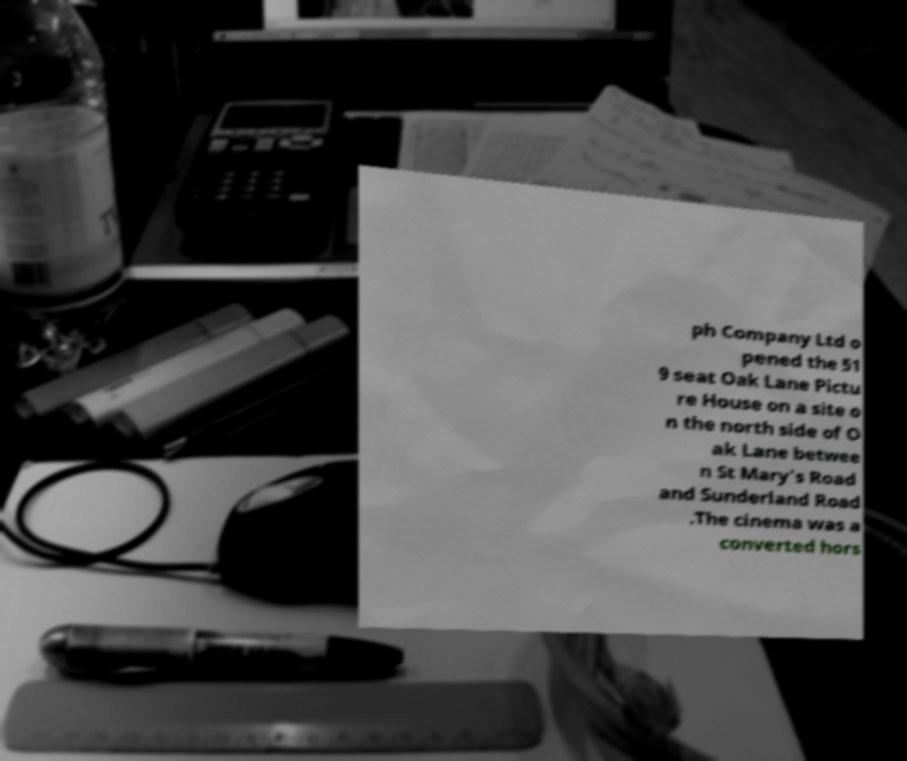There's text embedded in this image that I need extracted. Can you transcribe it verbatim? ph Company Ltd o pened the 51 9 seat Oak Lane Pictu re House on a site o n the north side of O ak Lane betwee n St Mary's Road and Sunderland Road .The cinema was a converted hors 